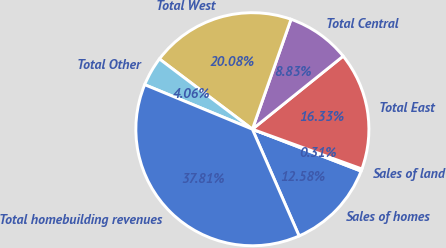Convert chart. <chart><loc_0><loc_0><loc_500><loc_500><pie_chart><fcel>Sales of homes<fcel>Sales of land<fcel>Total East<fcel>Total Central<fcel>Total West<fcel>Total Other<fcel>Total homebuilding revenues<nl><fcel>12.58%<fcel>0.31%<fcel>16.33%<fcel>8.83%<fcel>20.08%<fcel>4.06%<fcel>37.81%<nl></chart> 